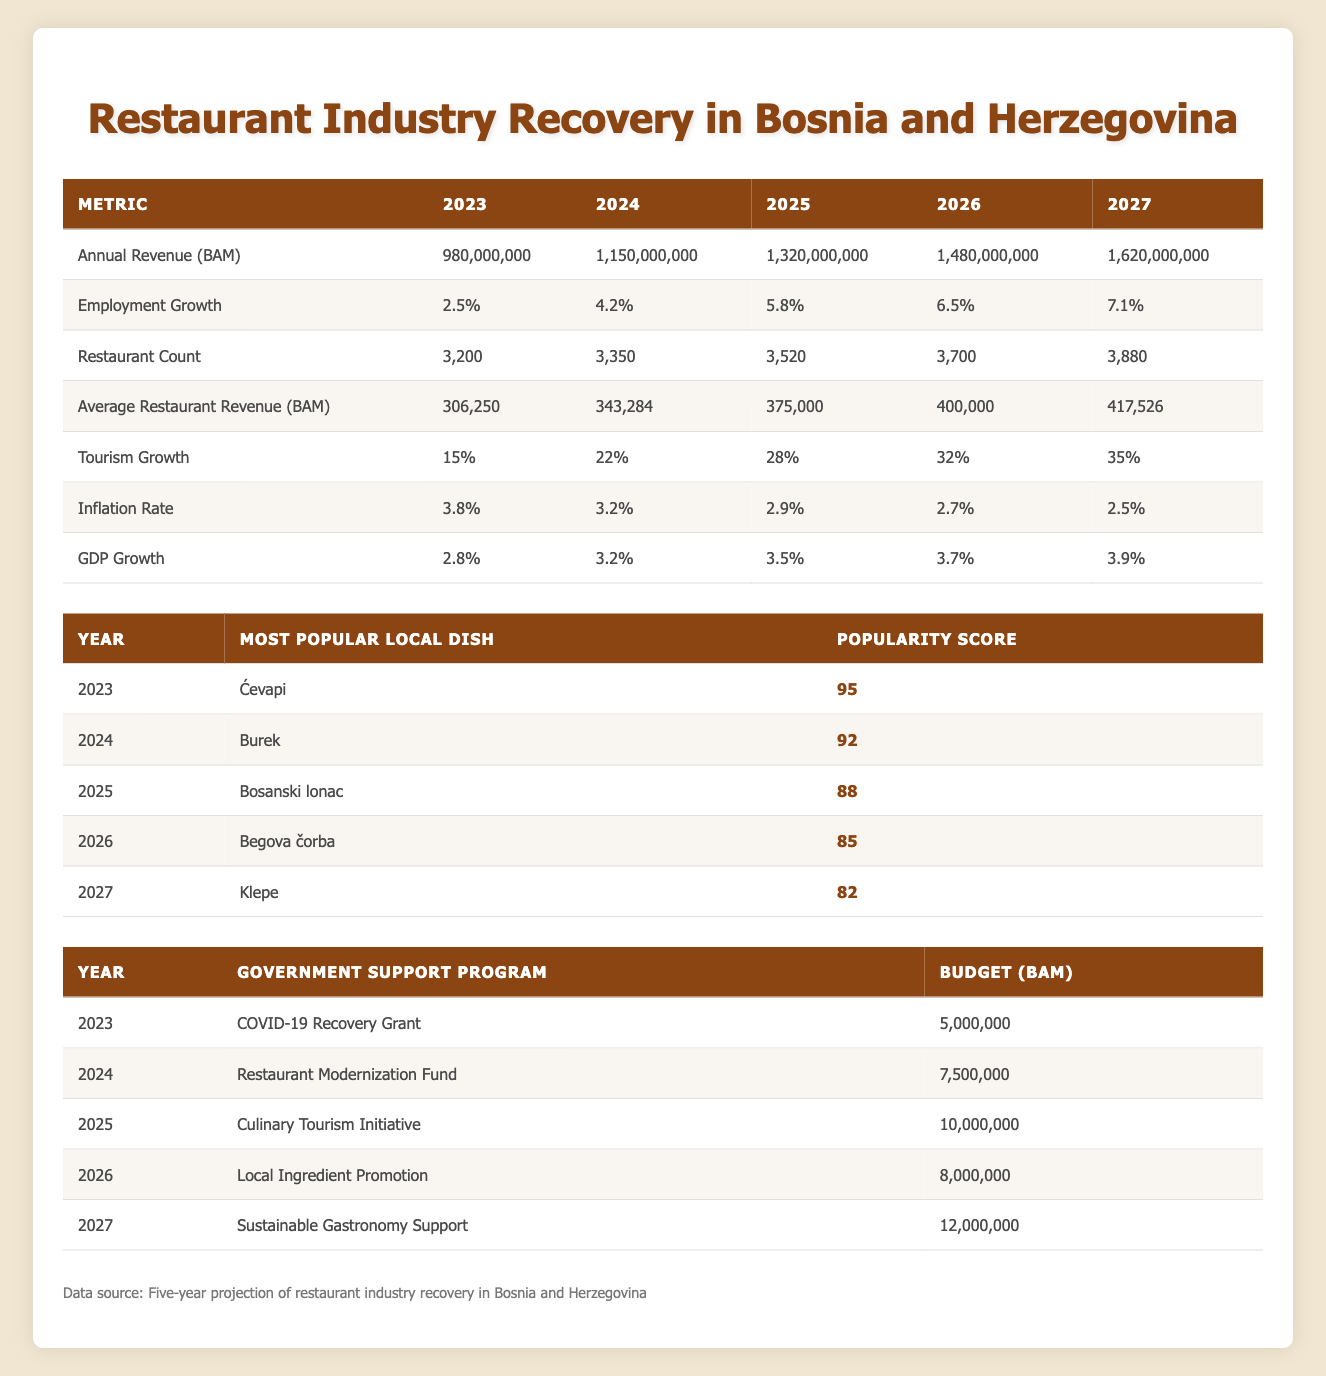What was the annual revenue for the restaurant industry in 2025? The table shows that the annual revenue for 2025 is listed under that year in the "Annual Revenue (BAM)" row, which is 1,320,000,000 BAM.
Answer: 1,320,000,000 BAM What is the average restaurant revenue projected for 2026? The table indicates that the average restaurant revenue for 2026 is directly listed under "Average Restaurant Revenue (BAM)" as 400,000 BAM.
Answer: 400,000 BAM Did the employment growth rate increase each year from 2023 to 2027? By examining the "Employment Growth" row, each year shows an increasing value from 2.5% in 2023 to 7.1% in 2027, confirming that the employment growth rate did indeed increase each year.
Answer: Yes What was the budget for the Culinary Tourism Initiative in 2025? The table specifies that the budget for the Culinary Tourism Initiative in 2025 is listed as 10,000,000 BAM under the "Budget (BAM)" column for that year.
Answer: 10,000,000 BAM What is the total projected annual revenue for the restaurant industry from 2023 to 2027? We sum the annual revenues across the years from the table: 980,000,000 + 1,150,000,000 + 1,320,000,000 + 1,480,000,000 + 1,620,000,000 = 6,550,000,000 BAM.
Answer: 6,550,000,000 BAM What is the popularity score for the most popular local dish in 2027? The table shows that the most popular local dish in 2027 is "Klepe," with a popularity score of 82, as indicated in the "Popularity Score" column.
Answer: 82 Was the inflation rate higher in 2023 compared to 2027? By checking the "Inflation Rate" row, the inflation rate in 2023 is 3.8%, while in 2027 it is 2.5%, so the inflation rate was higher in 2023.
Answer: Yes What was the average increase in the restaurant count from 2023 to 2027? The restaurant count shows an increase from 3,200 in 2023 to 3,880 in 2027, resulting in an increase of 680. To find the average annual increase, divide by 4 years: 680 / 4 = 170.
Answer: 170 What was the tourism growth percentage in 2024? Looking at the "Tourism Growth" row for the year 2024, the percentage is listed as 22%.
Answer: 22% 